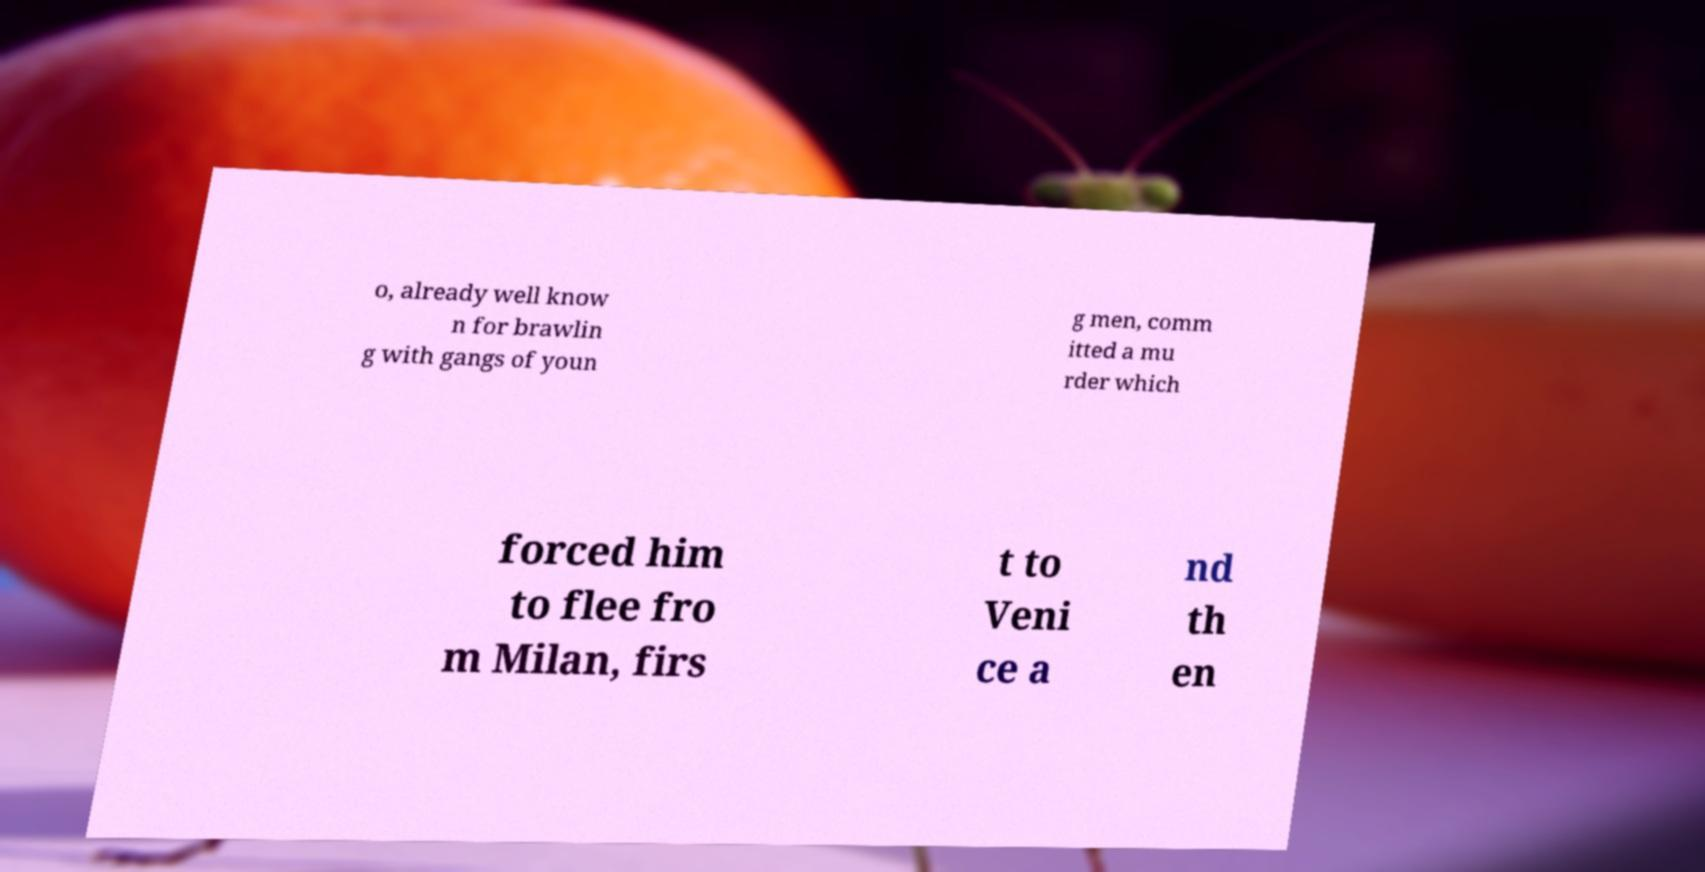For documentation purposes, I need the text within this image transcribed. Could you provide that? o, already well know n for brawlin g with gangs of youn g men, comm itted a mu rder which forced him to flee fro m Milan, firs t to Veni ce a nd th en 